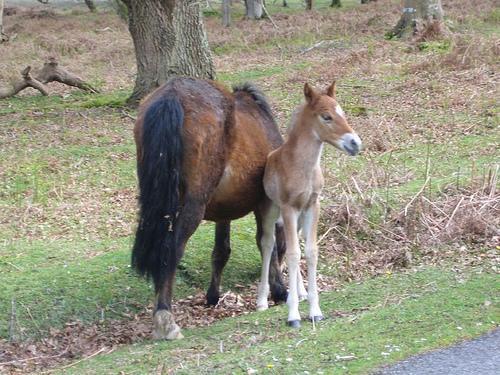How many horses can you see?
Give a very brief answer. 2. 